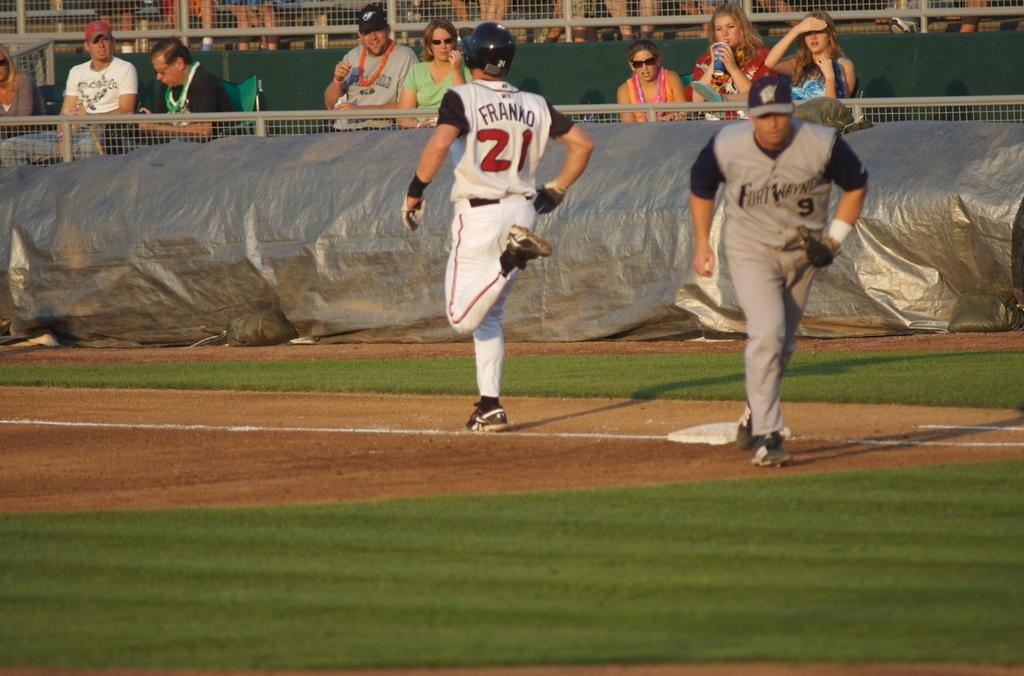What is #21s last name?
Your response must be concise. Franko. What is the player in grey's number?
Offer a very short reply. 9. 